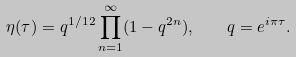<formula> <loc_0><loc_0><loc_500><loc_500>\eta ( \tau ) = q ^ { 1 / 1 2 } \prod _ { n = 1 } ^ { \infty } ( 1 - q ^ { 2 n } ) , \quad q = e ^ { i \pi \tau } .</formula> 